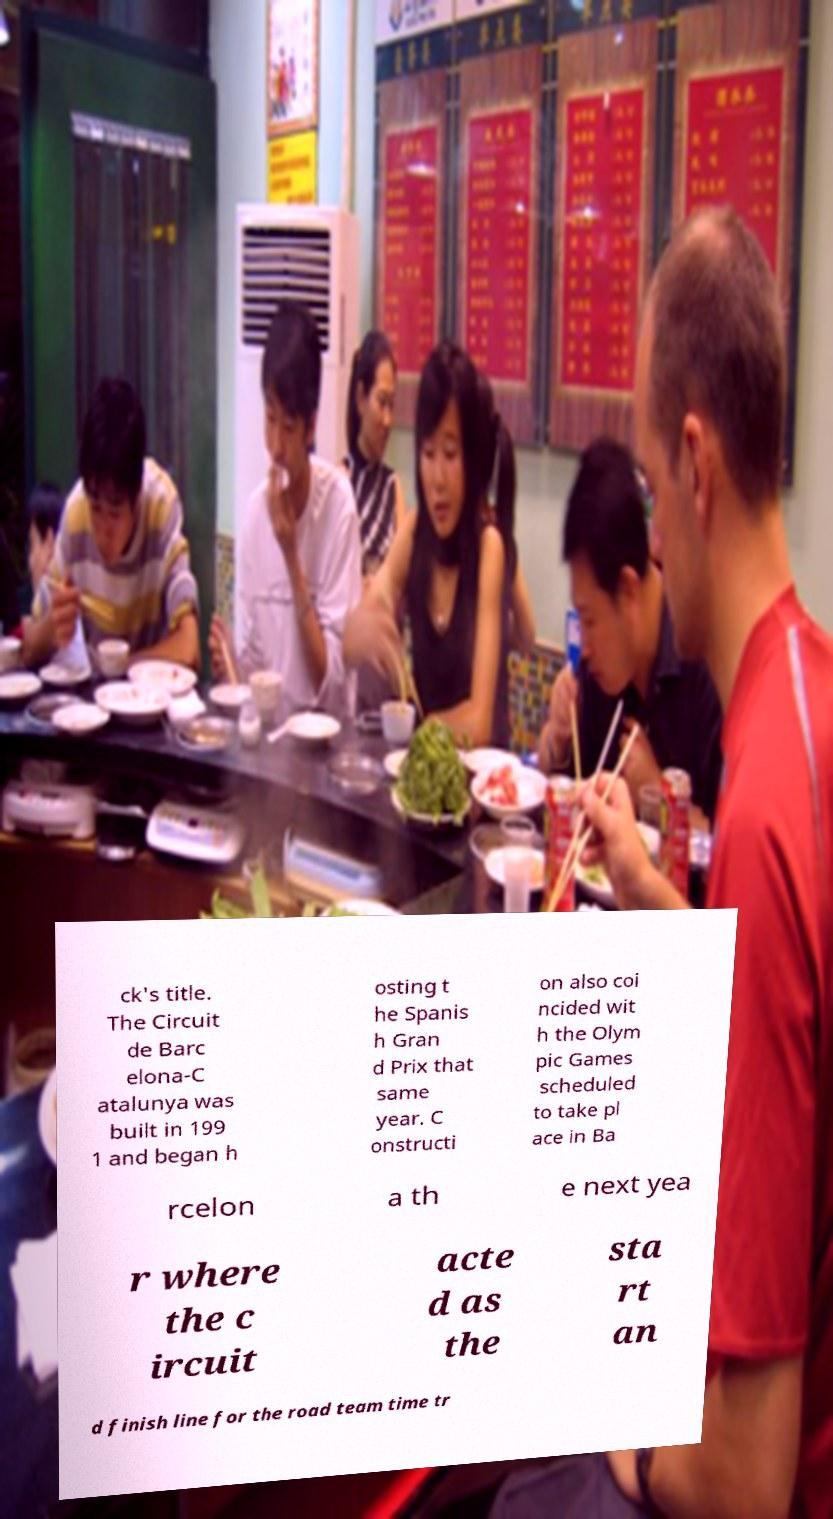Can you read and provide the text displayed in the image?This photo seems to have some interesting text. Can you extract and type it out for me? ck's title. The Circuit de Barc elona-C atalunya was built in 199 1 and began h osting t he Spanis h Gran d Prix that same year. C onstructi on also coi ncided wit h the Olym pic Games scheduled to take pl ace in Ba rcelon a th e next yea r where the c ircuit acte d as the sta rt an d finish line for the road team time tr 